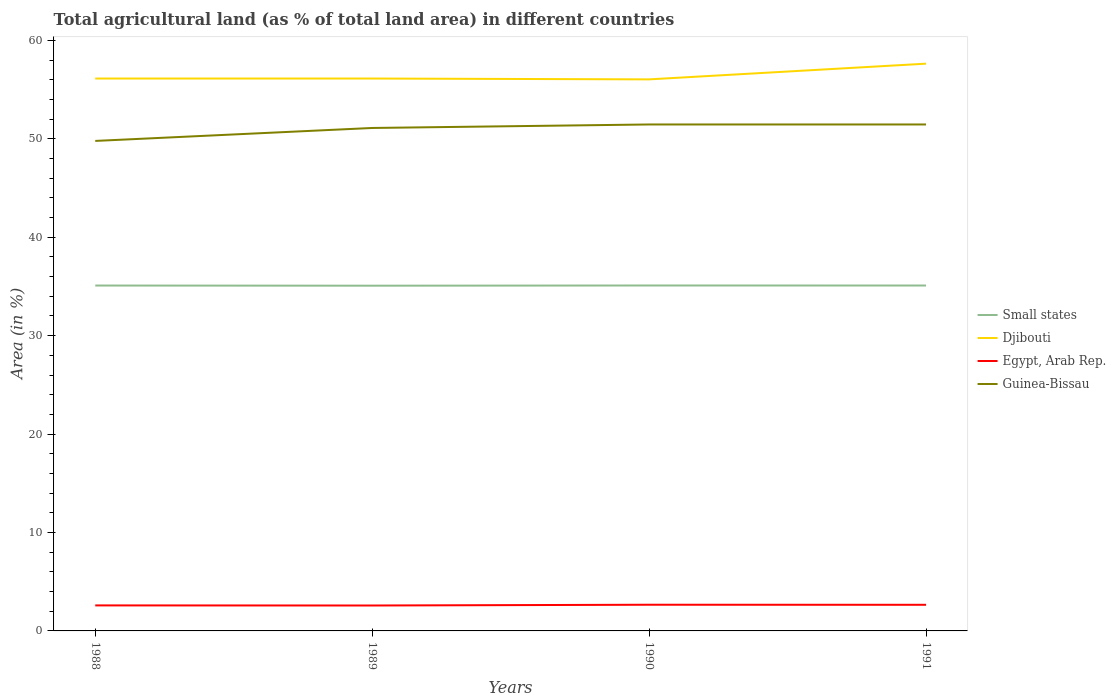Across all years, what is the maximum percentage of agricultural land in Egypt, Arab Rep.?
Provide a succinct answer. 2.58. In which year was the percentage of agricultural land in Egypt, Arab Rep. maximum?
Offer a terse response. 1989. What is the total percentage of agricultural land in Small states in the graph?
Make the answer very short. -0.02. What is the difference between the highest and the second highest percentage of agricultural land in Djibouti?
Provide a short and direct response. 1.6. How many years are there in the graph?
Give a very brief answer. 4. What is the difference between two consecutive major ticks on the Y-axis?
Give a very brief answer. 10. Are the values on the major ticks of Y-axis written in scientific E-notation?
Your response must be concise. No. Does the graph contain any zero values?
Make the answer very short. No. Does the graph contain grids?
Your answer should be compact. No. How many legend labels are there?
Your answer should be compact. 4. What is the title of the graph?
Your response must be concise. Total agricultural land (as % of total land area) in different countries. What is the label or title of the Y-axis?
Ensure brevity in your answer.  Area (in %). What is the Area (in %) in Small states in 1988?
Your answer should be very brief. 35.09. What is the Area (in %) of Djibouti in 1988?
Ensure brevity in your answer.  56.13. What is the Area (in %) in Egypt, Arab Rep. in 1988?
Ensure brevity in your answer.  2.59. What is the Area (in %) of Guinea-Bissau in 1988?
Provide a short and direct response. 49.79. What is the Area (in %) of Small states in 1989?
Offer a very short reply. 35.08. What is the Area (in %) in Djibouti in 1989?
Offer a terse response. 56.13. What is the Area (in %) in Egypt, Arab Rep. in 1989?
Keep it short and to the point. 2.58. What is the Area (in %) of Guinea-Bissau in 1989?
Give a very brief answer. 51.1. What is the Area (in %) in Small states in 1990?
Your answer should be compact. 35.1. What is the Area (in %) of Djibouti in 1990?
Offer a very short reply. 56.04. What is the Area (in %) of Egypt, Arab Rep. in 1990?
Offer a very short reply. 2.66. What is the Area (in %) of Guinea-Bissau in 1990?
Provide a short and direct response. 51.46. What is the Area (in %) in Small states in 1991?
Provide a short and direct response. 35.1. What is the Area (in %) in Djibouti in 1991?
Make the answer very short. 57.64. What is the Area (in %) of Egypt, Arab Rep. in 1991?
Your response must be concise. 2.66. What is the Area (in %) of Guinea-Bissau in 1991?
Ensure brevity in your answer.  51.46. Across all years, what is the maximum Area (in %) in Small states?
Your answer should be compact. 35.1. Across all years, what is the maximum Area (in %) in Djibouti?
Your answer should be very brief. 57.64. Across all years, what is the maximum Area (in %) in Egypt, Arab Rep.?
Ensure brevity in your answer.  2.66. Across all years, what is the maximum Area (in %) in Guinea-Bissau?
Ensure brevity in your answer.  51.46. Across all years, what is the minimum Area (in %) of Small states?
Your answer should be very brief. 35.08. Across all years, what is the minimum Area (in %) of Djibouti?
Your response must be concise. 56.04. Across all years, what is the minimum Area (in %) of Egypt, Arab Rep.?
Ensure brevity in your answer.  2.58. Across all years, what is the minimum Area (in %) of Guinea-Bissau?
Give a very brief answer. 49.79. What is the total Area (in %) of Small states in the graph?
Offer a very short reply. 140.36. What is the total Area (in %) of Djibouti in the graph?
Keep it short and to the point. 225.93. What is the total Area (in %) in Egypt, Arab Rep. in the graph?
Your answer should be compact. 10.49. What is the total Area (in %) of Guinea-Bissau in the graph?
Ensure brevity in your answer.  203.81. What is the difference between the Area (in %) of Small states in 1988 and that in 1989?
Your response must be concise. 0.02. What is the difference between the Area (in %) of Egypt, Arab Rep. in 1988 and that in 1989?
Your response must be concise. 0.01. What is the difference between the Area (in %) in Guinea-Bissau in 1988 and that in 1989?
Offer a terse response. -1.32. What is the difference between the Area (in %) of Small states in 1988 and that in 1990?
Make the answer very short. -0.01. What is the difference between the Area (in %) of Djibouti in 1988 and that in 1990?
Your response must be concise. 0.09. What is the difference between the Area (in %) of Egypt, Arab Rep. in 1988 and that in 1990?
Your response must be concise. -0.07. What is the difference between the Area (in %) in Guinea-Bissau in 1988 and that in 1990?
Provide a short and direct response. -1.67. What is the difference between the Area (in %) of Small states in 1988 and that in 1991?
Your answer should be very brief. -0. What is the difference between the Area (in %) of Djibouti in 1988 and that in 1991?
Offer a very short reply. -1.51. What is the difference between the Area (in %) of Egypt, Arab Rep. in 1988 and that in 1991?
Keep it short and to the point. -0.06. What is the difference between the Area (in %) in Guinea-Bissau in 1988 and that in 1991?
Provide a succinct answer. -1.67. What is the difference between the Area (in %) of Small states in 1989 and that in 1990?
Provide a succinct answer. -0.02. What is the difference between the Area (in %) of Djibouti in 1989 and that in 1990?
Ensure brevity in your answer.  0.09. What is the difference between the Area (in %) of Egypt, Arab Rep. in 1989 and that in 1990?
Give a very brief answer. -0.08. What is the difference between the Area (in %) of Guinea-Bissau in 1989 and that in 1990?
Your answer should be very brief. -0.36. What is the difference between the Area (in %) in Small states in 1989 and that in 1991?
Your answer should be compact. -0.02. What is the difference between the Area (in %) in Djibouti in 1989 and that in 1991?
Make the answer very short. -1.51. What is the difference between the Area (in %) of Egypt, Arab Rep. in 1989 and that in 1991?
Offer a very short reply. -0.07. What is the difference between the Area (in %) of Guinea-Bissau in 1989 and that in 1991?
Give a very brief answer. -0.36. What is the difference between the Area (in %) in Small states in 1990 and that in 1991?
Make the answer very short. 0. What is the difference between the Area (in %) of Djibouti in 1990 and that in 1991?
Keep it short and to the point. -1.6. What is the difference between the Area (in %) in Egypt, Arab Rep. in 1990 and that in 1991?
Give a very brief answer. 0.01. What is the difference between the Area (in %) in Guinea-Bissau in 1990 and that in 1991?
Provide a succinct answer. 0. What is the difference between the Area (in %) of Small states in 1988 and the Area (in %) of Djibouti in 1989?
Offer a very short reply. -21.03. What is the difference between the Area (in %) in Small states in 1988 and the Area (in %) in Egypt, Arab Rep. in 1989?
Provide a short and direct response. 32.51. What is the difference between the Area (in %) of Small states in 1988 and the Area (in %) of Guinea-Bissau in 1989?
Give a very brief answer. -16.01. What is the difference between the Area (in %) in Djibouti in 1988 and the Area (in %) in Egypt, Arab Rep. in 1989?
Ensure brevity in your answer.  53.54. What is the difference between the Area (in %) in Djibouti in 1988 and the Area (in %) in Guinea-Bissau in 1989?
Your answer should be very brief. 5.02. What is the difference between the Area (in %) of Egypt, Arab Rep. in 1988 and the Area (in %) of Guinea-Bissau in 1989?
Offer a very short reply. -48.51. What is the difference between the Area (in %) of Small states in 1988 and the Area (in %) of Djibouti in 1990?
Provide a short and direct response. -20.95. What is the difference between the Area (in %) of Small states in 1988 and the Area (in %) of Egypt, Arab Rep. in 1990?
Offer a terse response. 32.43. What is the difference between the Area (in %) in Small states in 1988 and the Area (in %) in Guinea-Bissau in 1990?
Provide a short and direct response. -16.37. What is the difference between the Area (in %) in Djibouti in 1988 and the Area (in %) in Egypt, Arab Rep. in 1990?
Ensure brevity in your answer.  53.47. What is the difference between the Area (in %) in Djibouti in 1988 and the Area (in %) in Guinea-Bissau in 1990?
Keep it short and to the point. 4.67. What is the difference between the Area (in %) of Egypt, Arab Rep. in 1988 and the Area (in %) of Guinea-Bissau in 1990?
Offer a terse response. -48.87. What is the difference between the Area (in %) of Small states in 1988 and the Area (in %) of Djibouti in 1991?
Provide a succinct answer. -22.54. What is the difference between the Area (in %) of Small states in 1988 and the Area (in %) of Egypt, Arab Rep. in 1991?
Your response must be concise. 32.44. What is the difference between the Area (in %) of Small states in 1988 and the Area (in %) of Guinea-Bissau in 1991?
Your answer should be compact. -16.37. What is the difference between the Area (in %) in Djibouti in 1988 and the Area (in %) in Egypt, Arab Rep. in 1991?
Provide a succinct answer. 53.47. What is the difference between the Area (in %) in Djibouti in 1988 and the Area (in %) in Guinea-Bissau in 1991?
Provide a short and direct response. 4.67. What is the difference between the Area (in %) of Egypt, Arab Rep. in 1988 and the Area (in %) of Guinea-Bissau in 1991?
Your answer should be very brief. -48.87. What is the difference between the Area (in %) of Small states in 1989 and the Area (in %) of Djibouti in 1990?
Keep it short and to the point. -20.96. What is the difference between the Area (in %) in Small states in 1989 and the Area (in %) in Egypt, Arab Rep. in 1990?
Your response must be concise. 32.42. What is the difference between the Area (in %) in Small states in 1989 and the Area (in %) in Guinea-Bissau in 1990?
Ensure brevity in your answer.  -16.38. What is the difference between the Area (in %) of Djibouti in 1989 and the Area (in %) of Egypt, Arab Rep. in 1990?
Your response must be concise. 53.47. What is the difference between the Area (in %) of Djibouti in 1989 and the Area (in %) of Guinea-Bissau in 1990?
Offer a very short reply. 4.67. What is the difference between the Area (in %) of Egypt, Arab Rep. in 1989 and the Area (in %) of Guinea-Bissau in 1990?
Your answer should be compact. -48.88. What is the difference between the Area (in %) of Small states in 1989 and the Area (in %) of Djibouti in 1991?
Make the answer very short. -22.56. What is the difference between the Area (in %) in Small states in 1989 and the Area (in %) in Egypt, Arab Rep. in 1991?
Your answer should be compact. 32.42. What is the difference between the Area (in %) of Small states in 1989 and the Area (in %) of Guinea-Bissau in 1991?
Your response must be concise. -16.38. What is the difference between the Area (in %) of Djibouti in 1989 and the Area (in %) of Egypt, Arab Rep. in 1991?
Your answer should be very brief. 53.47. What is the difference between the Area (in %) of Djibouti in 1989 and the Area (in %) of Guinea-Bissau in 1991?
Your answer should be compact. 4.67. What is the difference between the Area (in %) of Egypt, Arab Rep. in 1989 and the Area (in %) of Guinea-Bissau in 1991?
Give a very brief answer. -48.88. What is the difference between the Area (in %) of Small states in 1990 and the Area (in %) of Djibouti in 1991?
Your answer should be very brief. -22.54. What is the difference between the Area (in %) in Small states in 1990 and the Area (in %) in Egypt, Arab Rep. in 1991?
Your answer should be very brief. 32.44. What is the difference between the Area (in %) of Small states in 1990 and the Area (in %) of Guinea-Bissau in 1991?
Your answer should be compact. -16.36. What is the difference between the Area (in %) of Djibouti in 1990 and the Area (in %) of Egypt, Arab Rep. in 1991?
Your response must be concise. 53.38. What is the difference between the Area (in %) of Djibouti in 1990 and the Area (in %) of Guinea-Bissau in 1991?
Make the answer very short. 4.58. What is the difference between the Area (in %) in Egypt, Arab Rep. in 1990 and the Area (in %) in Guinea-Bissau in 1991?
Provide a short and direct response. -48.8. What is the average Area (in %) of Small states per year?
Your response must be concise. 35.09. What is the average Area (in %) in Djibouti per year?
Provide a succinct answer. 56.48. What is the average Area (in %) of Egypt, Arab Rep. per year?
Your response must be concise. 2.62. What is the average Area (in %) in Guinea-Bissau per year?
Offer a terse response. 50.95. In the year 1988, what is the difference between the Area (in %) in Small states and Area (in %) in Djibouti?
Provide a succinct answer. -21.03. In the year 1988, what is the difference between the Area (in %) of Small states and Area (in %) of Egypt, Arab Rep.?
Keep it short and to the point. 32.5. In the year 1988, what is the difference between the Area (in %) of Small states and Area (in %) of Guinea-Bissau?
Provide a short and direct response. -14.69. In the year 1988, what is the difference between the Area (in %) in Djibouti and Area (in %) in Egypt, Arab Rep.?
Offer a terse response. 53.53. In the year 1988, what is the difference between the Area (in %) in Djibouti and Area (in %) in Guinea-Bissau?
Keep it short and to the point. 6.34. In the year 1988, what is the difference between the Area (in %) of Egypt, Arab Rep. and Area (in %) of Guinea-Bissau?
Offer a very short reply. -47.19. In the year 1989, what is the difference between the Area (in %) of Small states and Area (in %) of Djibouti?
Keep it short and to the point. -21.05. In the year 1989, what is the difference between the Area (in %) of Small states and Area (in %) of Egypt, Arab Rep.?
Your answer should be very brief. 32.49. In the year 1989, what is the difference between the Area (in %) in Small states and Area (in %) in Guinea-Bissau?
Ensure brevity in your answer.  -16.03. In the year 1989, what is the difference between the Area (in %) of Djibouti and Area (in %) of Egypt, Arab Rep.?
Offer a terse response. 53.54. In the year 1989, what is the difference between the Area (in %) of Djibouti and Area (in %) of Guinea-Bissau?
Your answer should be compact. 5.02. In the year 1989, what is the difference between the Area (in %) of Egypt, Arab Rep. and Area (in %) of Guinea-Bissau?
Provide a succinct answer. -48.52. In the year 1990, what is the difference between the Area (in %) of Small states and Area (in %) of Djibouti?
Give a very brief answer. -20.94. In the year 1990, what is the difference between the Area (in %) of Small states and Area (in %) of Egypt, Arab Rep.?
Keep it short and to the point. 32.44. In the year 1990, what is the difference between the Area (in %) of Small states and Area (in %) of Guinea-Bissau?
Ensure brevity in your answer.  -16.36. In the year 1990, what is the difference between the Area (in %) in Djibouti and Area (in %) in Egypt, Arab Rep.?
Your answer should be compact. 53.38. In the year 1990, what is the difference between the Area (in %) in Djibouti and Area (in %) in Guinea-Bissau?
Provide a short and direct response. 4.58. In the year 1990, what is the difference between the Area (in %) of Egypt, Arab Rep. and Area (in %) of Guinea-Bissau?
Give a very brief answer. -48.8. In the year 1991, what is the difference between the Area (in %) in Small states and Area (in %) in Djibouti?
Offer a terse response. -22.54. In the year 1991, what is the difference between the Area (in %) of Small states and Area (in %) of Egypt, Arab Rep.?
Your answer should be compact. 32.44. In the year 1991, what is the difference between the Area (in %) of Small states and Area (in %) of Guinea-Bissau?
Keep it short and to the point. -16.36. In the year 1991, what is the difference between the Area (in %) of Djibouti and Area (in %) of Egypt, Arab Rep.?
Provide a succinct answer. 54.98. In the year 1991, what is the difference between the Area (in %) of Djibouti and Area (in %) of Guinea-Bissau?
Keep it short and to the point. 6.18. In the year 1991, what is the difference between the Area (in %) of Egypt, Arab Rep. and Area (in %) of Guinea-Bissau?
Your response must be concise. -48.8. What is the ratio of the Area (in %) of Small states in 1988 to that in 1989?
Give a very brief answer. 1. What is the ratio of the Area (in %) of Guinea-Bissau in 1988 to that in 1989?
Ensure brevity in your answer.  0.97. What is the ratio of the Area (in %) in Egypt, Arab Rep. in 1988 to that in 1990?
Ensure brevity in your answer.  0.97. What is the ratio of the Area (in %) of Guinea-Bissau in 1988 to that in 1990?
Offer a very short reply. 0.97. What is the ratio of the Area (in %) of Small states in 1988 to that in 1991?
Provide a succinct answer. 1. What is the ratio of the Area (in %) of Djibouti in 1988 to that in 1991?
Ensure brevity in your answer.  0.97. What is the ratio of the Area (in %) of Egypt, Arab Rep. in 1988 to that in 1991?
Give a very brief answer. 0.98. What is the ratio of the Area (in %) in Guinea-Bissau in 1988 to that in 1991?
Provide a succinct answer. 0.97. What is the ratio of the Area (in %) in Small states in 1989 to that in 1990?
Offer a very short reply. 1. What is the ratio of the Area (in %) in Egypt, Arab Rep. in 1989 to that in 1990?
Provide a succinct answer. 0.97. What is the ratio of the Area (in %) in Djibouti in 1989 to that in 1991?
Your response must be concise. 0.97. What is the ratio of the Area (in %) in Egypt, Arab Rep. in 1989 to that in 1991?
Provide a short and direct response. 0.97. What is the ratio of the Area (in %) in Guinea-Bissau in 1989 to that in 1991?
Your answer should be compact. 0.99. What is the ratio of the Area (in %) in Small states in 1990 to that in 1991?
Provide a succinct answer. 1. What is the ratio of the Area (in %) of Djibouti in 1990 to that in 1991?
Your answer should be compact. 0.97. What is the ratio of the Area (in %) in Egypt, Arab Rep. in 1990 to that in 1991?
Make the answer very short. 1. What is the ratio of the Area (in %) of Guinea-Bissau in 1990 to that in 1991?
Your response must be concise. 1. What is the difference between the highest and the second highest Area (in %) of Small states?
Provide a succinct answer. 0. What is the difference between the highest and the second highest Area (in %) of Djibouti?
Your answer should be very brief. 1.51. What is the difference between the highest and the second highest Area (in %) in Egypt, Arab Rep.?
Your response must be concise. 0.01. What is the difference between the highest and the second highest Area (in %) in Guinea-Bissau?
Offer a very short reply. 0. What is the difference between the highest and the lowest Area (in %) in Small states?
Ensure brevity in your answer.  0.02. What is the difference between the highest and the lowest Area (in %) of Djibouti?
Your answer should be compact. 1.6. What is the difference between the highest and the lowest Area (in %) of Egypt, Arab Rep.?
Keep it short and to the point. 0.08. What is the difference between the highest and the lowest Area (in %) in Guinea-Bissau?
Provide a short and direct response. 1.67. 